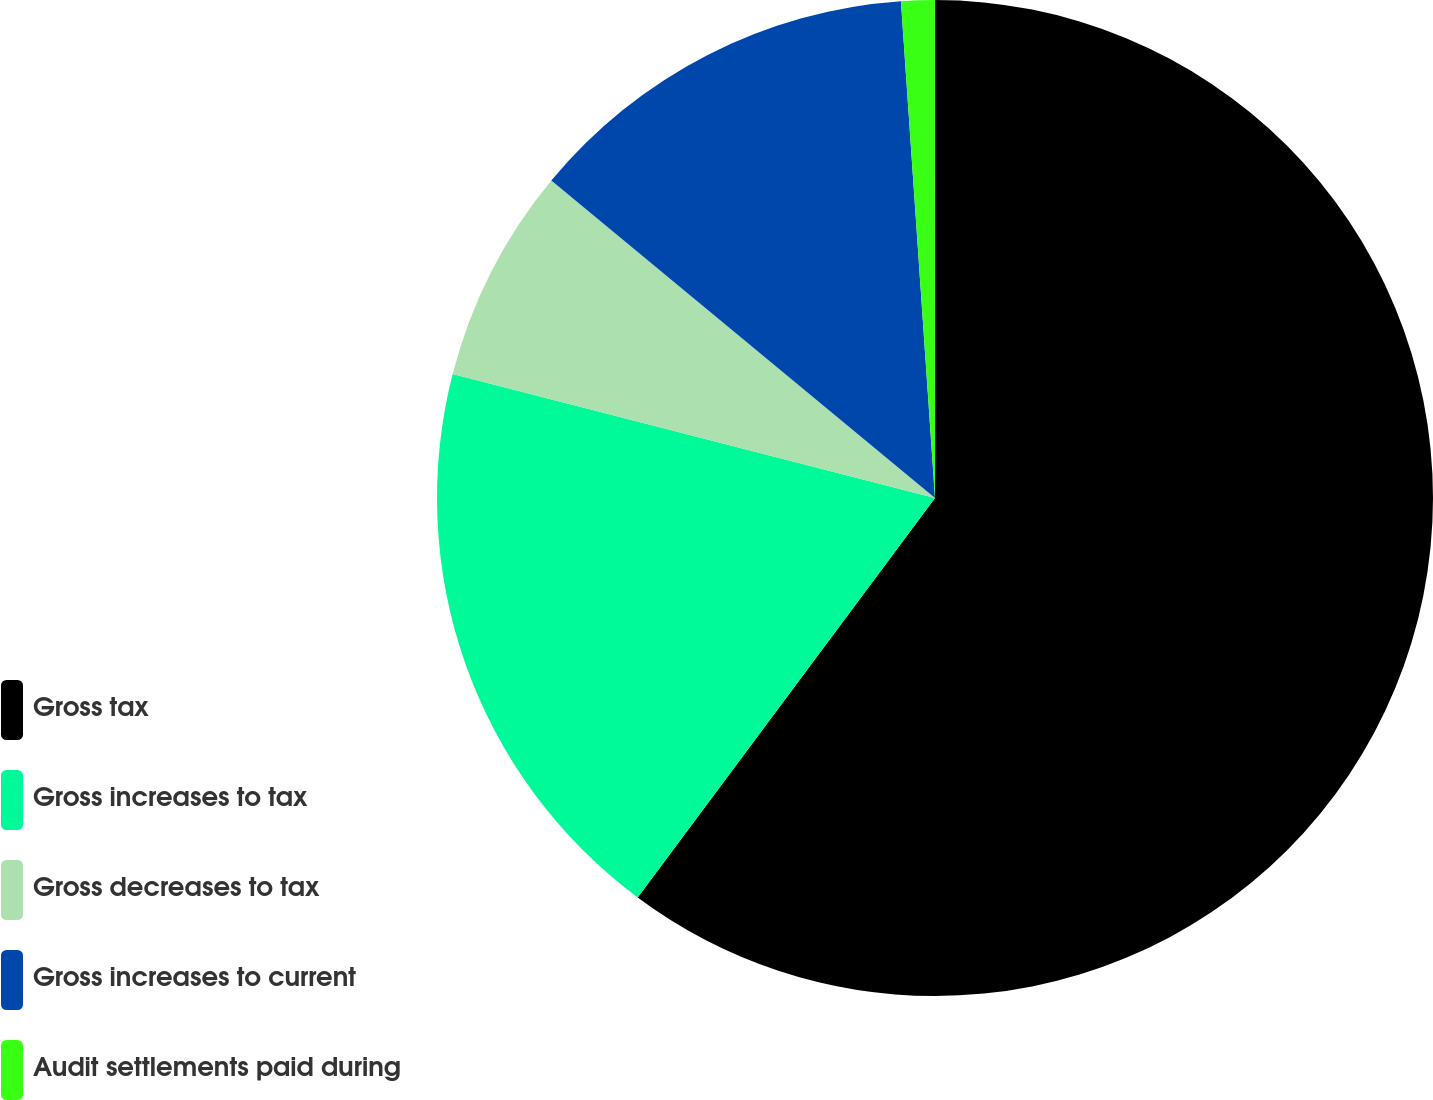Convert chart to OTSL. <chart><loc_0><loc_0><loc_500><loc_500><pie_chart><fcel>Gross tax<fcel>Gross increases to tax<fcel>Gross decreases to tax<fcel>Gross increases to current<fcel>Audit settlements paid during<nl><fcel>60.19%<fcel>18.82%<fcel>7.0%<fcel>12.91%<fcel>1.09%<nl></chart> 